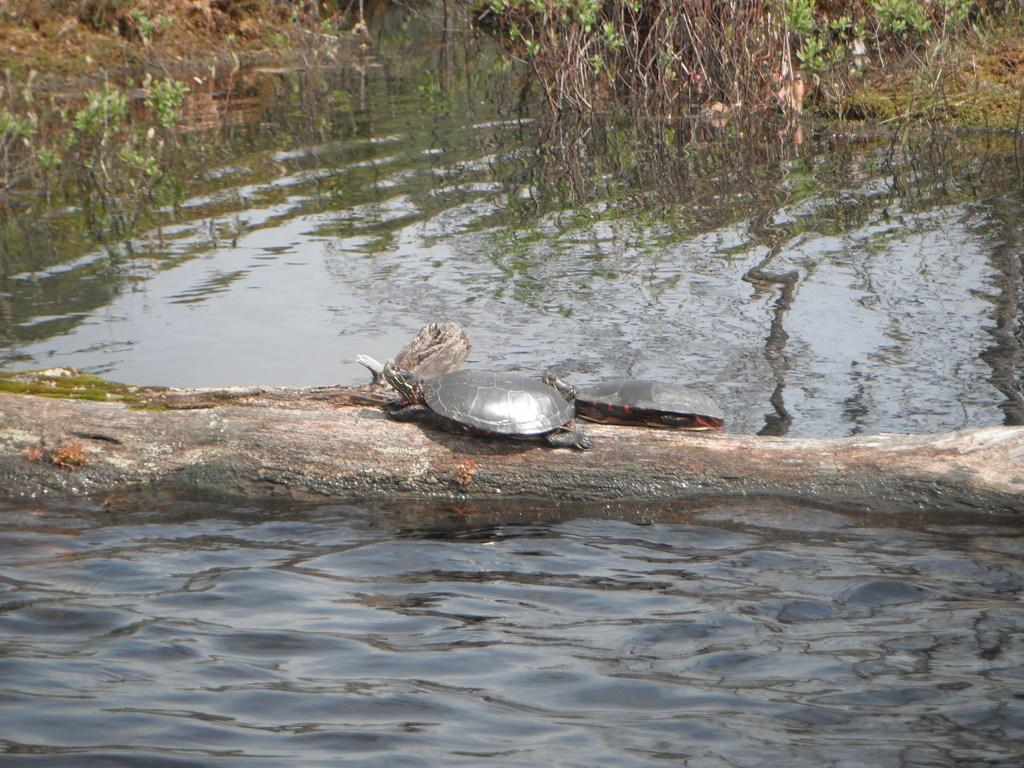What animal is present in the image? There is a tortoise in the image. What is the tortoise resting on? The tortoise is on a wooden surface. What can be seen in the background of the image? There is water and green plants visible in the background of the image. What type of fact can be seen in the image? There is no fact present in the image; it features a tortoise on a wooden surface with a background of water and green plants. 